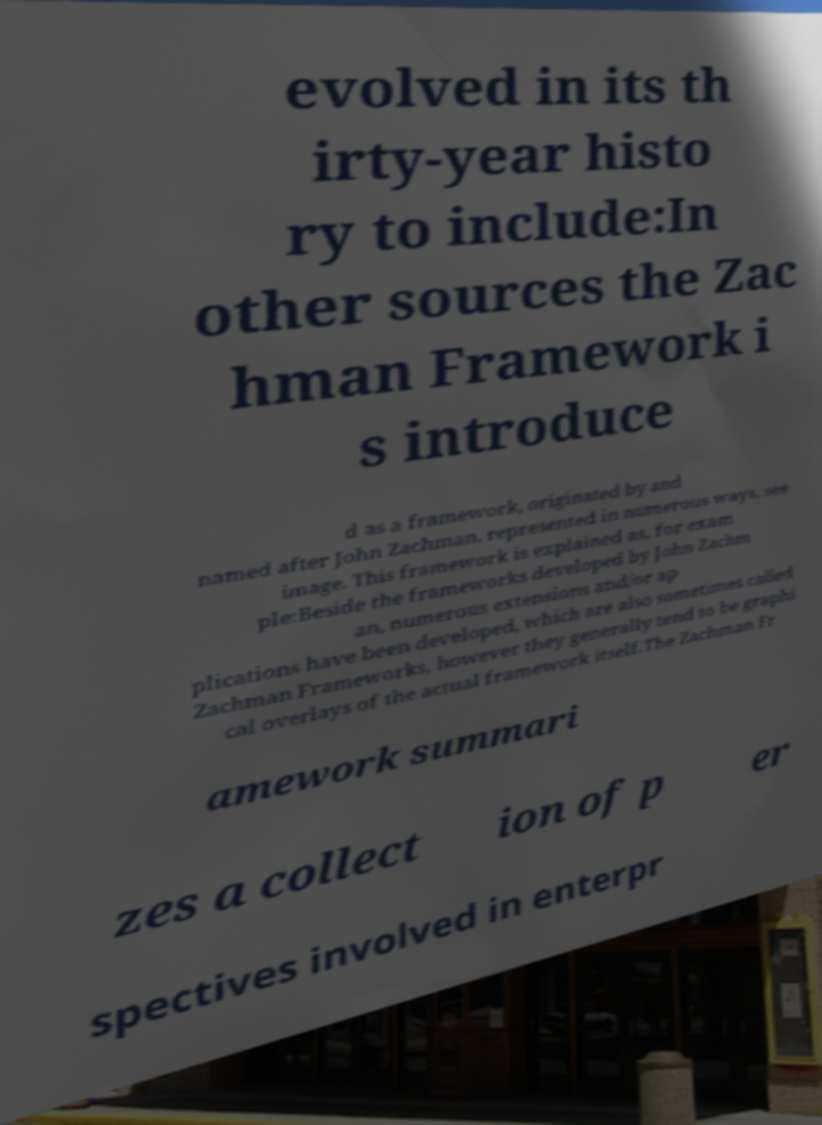I need the written content from this picture converted into text. Can you do that? evolved in its th irty-year histo ry to include:In other sources the Zac hman Framework i s introduce d as a framework, originated by and named after John Zachman, represented in numerous ways, see image. This framework is explained as, for exam ple:Beside the frameworks developed by John Zachm an, numerous extensions and/or ap plications have been developed, which are also sometimes called Zachman Frameworks, however they generally tend to be graphi cal overlays of the actual framework itself.The Zachman Fr amework summari zes a collect ion of p er spectives involved in enterpr 